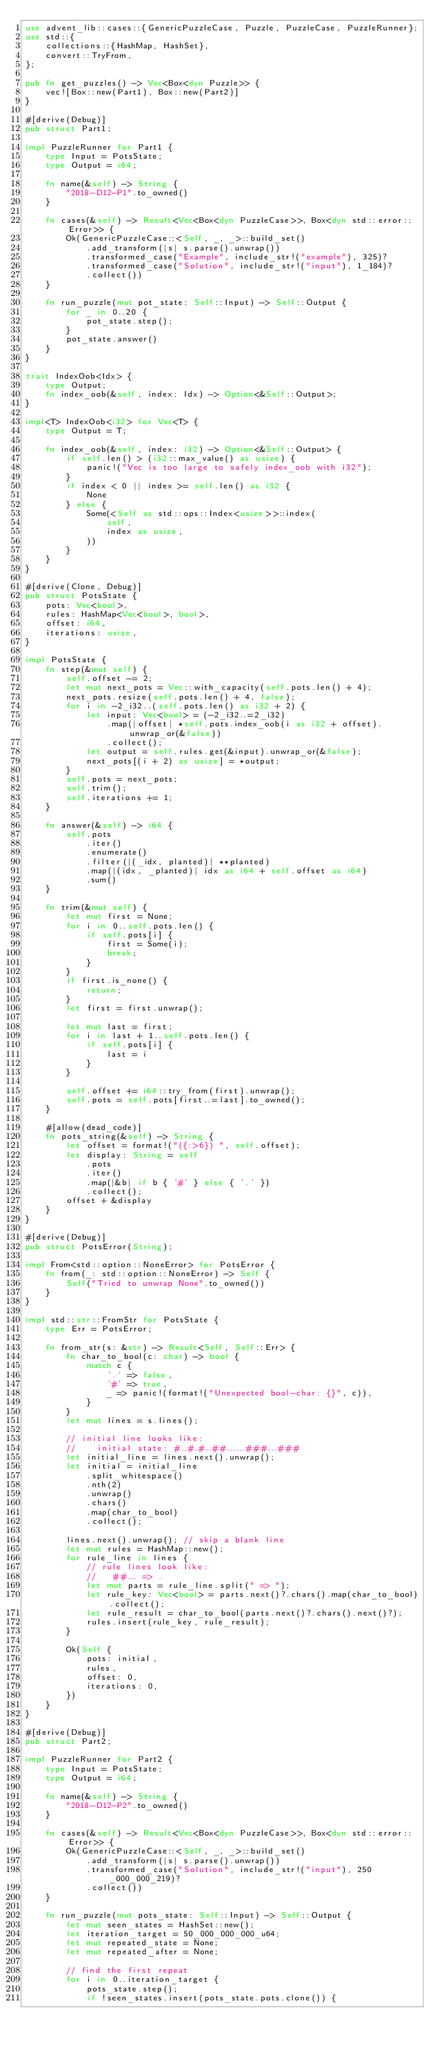<code> <loc_0><loc_0><loc_500><loc_500><_Rust_>use advent_lib::cases::{GenericPuzzleCase, Puzzle, PuzzleCase, PuzzleRunner};
use std::{
    collections::{HashMap, HashSet},
    convert::TryFrom,
};

pub fn get_puzzles() -> Vec<Box<dyn Puzzle>> {
    vec![Box::new(Part1), Box::new(Part2)]
}

#[derive(Debug)]
pub struct Part1;

impl PuzzleRunner for Part1 {
    type Input = PotsState;
    type Output = i64;

    fn name(&self) -> String {
        "2018-D12-P1".to_owned()
    }

    fn cases(&self) -> Result<Vec<Box<dyn PuzzleCase>>, Box<dyn std::error::Error>> {
        Ok(GenericPuzzleCase::<Self, _, _>::build_set()
            .add_transform(|s| s.parse().unwrap())
            .transformed_case("Example", include_str!("example"), 325)?
            .transformed_case("Solution", include_str!("input"), 1_184)?
            .collect())
    }

    fn run_puzzle(mut pot_state: Self::Input) -> Self::Output {
        for _ in 0..20 {
            pot_state.step();
        }
        pot_state.answer()
    }
}

trait IndexOob<Idx> {
    type Output;
    fn index_oob(&self, index: Idx) -> Option<&Self::Output>;
}

impl<T> IndexOob<i32> for Vec<T> {
    type Output = T;

    fn index_oob(&self, index: i32) -> Option<&Self::Output> {
        if self.len() > (i32::max_value() as usize) {
            panic!("Vec is too large to safely index_oob with i32");
        }
        if index < 0 || index >= self.len() as i32 {
            None
        } else {
            Some(<Self as std::ops::Index<usize>>::index(
                self,
                index as usize,
            ))
        }
    }
}

#[derive(Clone, Debug)]
pub struct PotsState {
    pots: Vec<bool>,
    rules: HashMap<Vec<bool>, bool>,
    offset: i64,
    iterations: usize,
}

impl PotsState {
    fn step(&mut self) {
        self.offset -= 2;
        let mut next_pots = Vec::with_capacity(self.pots.len() + 4);
        next_pots.resize(self.pots.len() + 4, false);
        for i in -2_i32..(self.pots.len() as i32 + 2) {
            let input: Vec<bool> = (-2_i32..=2_i32)
                .map(|offset| *self.pots.index_oob(i as i32 + offset).unwrap_or(&false))
                .collect();
            let output = self.rules.get(&input).unwrap_or(&false);
            next_pots[(i + 2) as usize] = *output;
        }
        self.pots = next_pots;
        self.trim();
        self.iterations += 1;
    }

    fn answer(&self) -> i64 {
        self.pots
            .iter()
            .enumerate()
            .filter(|(_idx, planted)| **planted)
            .map(|(idx, _planted)| idx as i64 + self.offset as i64)
            .sum()
    }

    fn trim(&mut self) {
        let mut first = None;
        for i in 0..self.pots.len() {
            if self.pots[i] {
                first = Some(i);
                break;
            }
        }
        if first.is_none() {
            return;
        }
        let first = first.unwrap();

        let mut last = first;
        for i in last + 1..self.pots.len() {
            if self.pots[i] {
                last = i
            }
        }

        self.offset += i64::try_from(first).unwrap();
        self.pots = self.pots[first..=last].to_owned();
    }

    #[allow(dead_code)]
    fn pots_string(&self) -> String {
        let offset = format!("({:>6}) ", self.offset);
        let display: String = self
            .pots
            .iter()
            .map(|&b| if b { '#' } else { '.' })
            .collect();
        offset + &display
    }
}

#[derive(Debug)]
pub struct PotsError(String);

impl From<std::option::NoneError> for PotsError {
    fn from(_: std::option::NoneError) -> Self {
        Self("Tried to unwrap None".to_owned())
    }
}

impl std::str::FromStr for PotsState {
    type Err = PotsError;

    fn from_str(s: &str) -> Result<Self, Self::Err> {
        fn char_to_bool(c: char) -> bool {
            match c {
                '.' => false,
                '#' => true,
                _ => panic!(format!("Unexpected bool-char: {}", c)),
            }
        }
        let mut lines = s.lines();

        // initial line looks like:
        //    initial state: #..#.#..##......###...###
        let initial_line = lines.next().unwrap();
        let initial = initial_line
            .split_whitespace()
            .nth(2)
            .unwrap()
            .chars()
            .map(char_to_bool)
            .collect();

        lines.next().unwrap(); // skip a blank line
        let mut rules = HashMap::new();
        for rule_line in lines {
            // rule lines look like:
            //   ##... => .
            let mut parts = rule_line.split(" => ");
            let rule_key: Vec<bool> = parts.next()?.chars().map(char_to_bool).collect();
            let rule_result = char_to_bool(parts.next()?.chars().next()?);
            rules.insert(rule_key, rule_result);
        }

        Ok(Self {
            pots: initial,
            rules,
            offset: 0,
            iterations: 0,
        })
    }
}

#[derive(Debug)]
pub struct Part2;

impl PuzzleRunner for Part2 {
    type Input = PotsState;
    type Output = i64;

    fn name(&self) -> String {
        "2018-D12-P2".to_owned()
    }

    fn cases(&self) -> Result<Vec<Box<dyn PuzzleCase>>, Box<dyn std::error::Error>> {
        Ok(GenericPuzzleCase::<Self, _, _>::build_set()
            .add_transform(|s| s.parse().unwrap())
            .transformed_case("Solution", include_str!("input"), 250_000_000_219)?
            .collect())
    }

    fn run_puzzle(mut pots_state: Self::Input) -> Self::Output {
        let mut seen_states = HashSet::new();
        let iteration_target = 50_000_000_000_u64;
        let mut repeated_state = None;
        let mut repeated_after = None;

        // find the first repeat
        for i in 0..iteration_target {
            pots_state.step();
            if !seen_states.insert(pots_state.pots.clone()) {</code> 